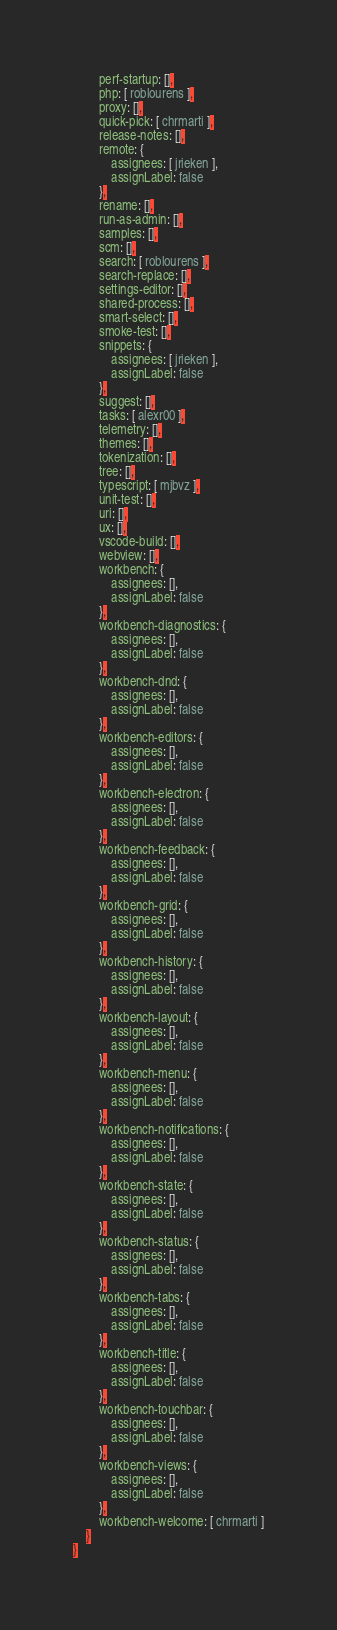Convert code to text. <code><loc_0><loc_0><loc_500><loc_500><_YAML_>        perf-startup: [],
        php: [ roblourens ],
        proxy: [],
        quick-pick: [ chrmarti ],
        release-notes: [],
        remote: {
            assignees: [ jrieken ],
            assignLabel: false
        },
        rename: [],
        run-as-admin: [],
        samples: [],
        scm: [],
        search: [ roblourens ],
        search-replace: [],
        settings-editor: [],
        shared-process: [],
        smart-select: [],
        smoke-test: [],
        snippets: {
            assignees: [ jrieken ],
            assignLabel: false
        },
        suggest: [],
        tasks: [ alexr00 ],
        telemetry: [],
        themes: [],
        tokenization: [],
        tree: [],
        typescript: [ mjbvz ],
        unit-test: [],
        uri: [],
        ux: [],
        vscode-build: [],
        webview: [],
        workbench: {
            assignees: [],
            assignLabel: false
        },
        workbench-diagnostics: {
            assignees: [],
            assignLabel: false
        },
        workbench-dnd: {
            assignees: [],
            assignLabel: false
        },
        workbench-editors: {
            assignees: [],
            assignLabel: false
        },
        workbench-electron: {
            assignees: [],
            assignLabel: false
        },
        workbench-feedback: {
            assignees: [],
            assignLabel: false
        },
        workbench-grid: {
            assignees: [],
            assignLabel: false
        },
        workbench-history: {
            assignees: [],
            assignLabel: false
        },
        workbench-layout: {
            assignees: [],
            assignLabel: false
        },
        workbench-menu: {
            assignees: [],
            assignLabel: false
        },
        workbench-notifications: {
            assignees: [],
            assignLabel: false
        },
        workbench-state: {
            assignees: [],
            assignLabel: false
        },
        workbench-status: {
            assignees: [],
            assignLabel: false
        },
        workbench-tabs: {
            assignees: [],
            assignLabel: false
        },
        workbench-title: {
            assignees: [],
            assignLabel: false
        },
        workbench-touchbar: {
            assignees: [],
            assignLabel: false
        },
        workbench-views: {
            assignees: [],
            assignLabel: false
        },
        workbench-welcome: [ chrmarti ]
    }
}
</code> 